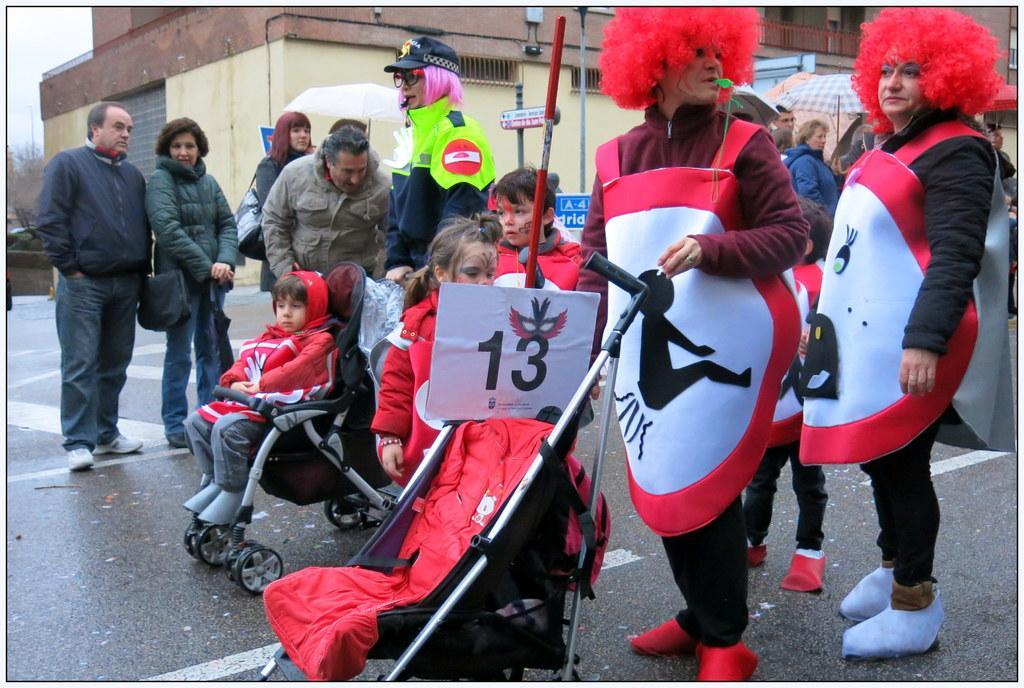Can you describe this image briefly? In the image we can see there are kids sitting in a buggy and people are holding it. They are wearing a costume and there is a red colour hair costume on their head. The man is holding a whistle in his mouth and other people are standing on the road and they are wearing jackets. 